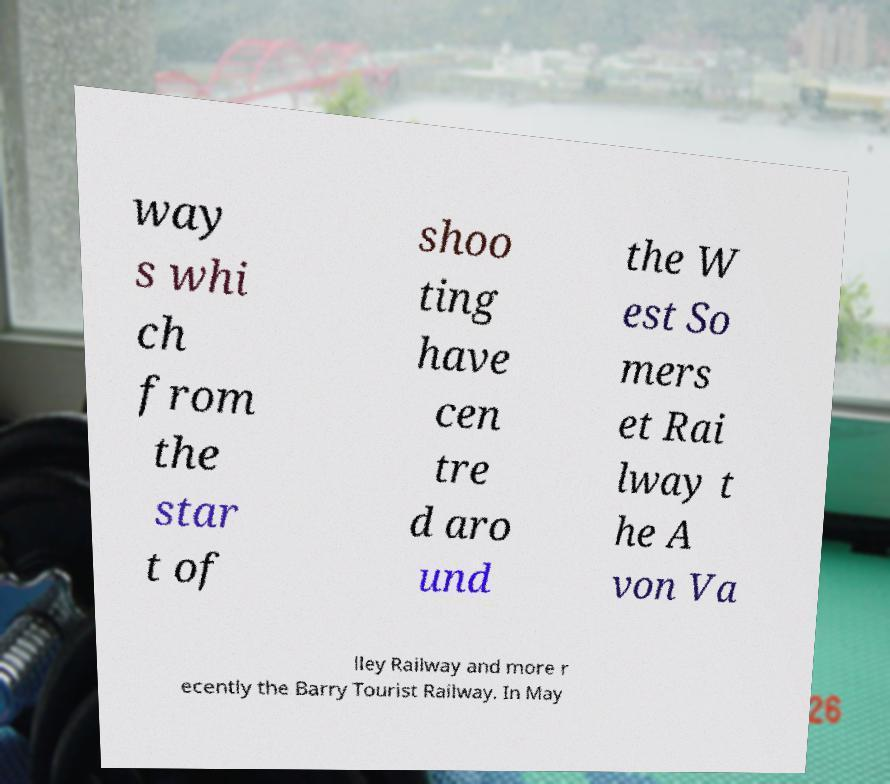For documentation purposes, I need the text within this image transcribed. Could you provide that? way s whi ch from the star t of shoo ting have cen tre d aro und the W est So mers et Rai lway t he A von Va lley Railway and more r ecently the Barry Tourist Railway. In May 